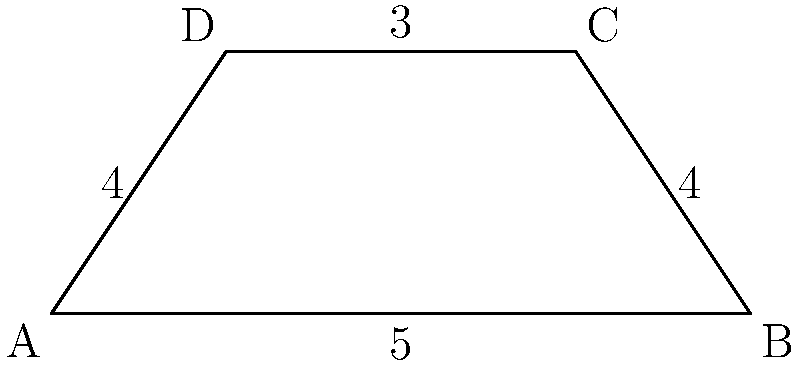A trapezoid ABCD has parallel sides AD and BC. Given that AB = 5 cm, BC = 4 cm, CD = 3 cm, and DA = 4 cm, calculate the perimeter of the trapezoid. To calculate the perimeter of the trapezoid, we need to sum up the lengths of all four sides:

1. Side AB = 5 cm
2. Side BC = 4 cm
3. Side CD = 3 cm
4. Side DA = 4 cm

The perimeter is the sum of these lengths:

$$\text{Perimeter} = AB + BC + CD + DA$$
$$\text{Perimeter} = 5 + 4 + 3 + 4 = 16 \text{ cm}$$

Therefore, the perimeter of the trapezoid ABCD is 16 cm.
Answer: 16 cm 